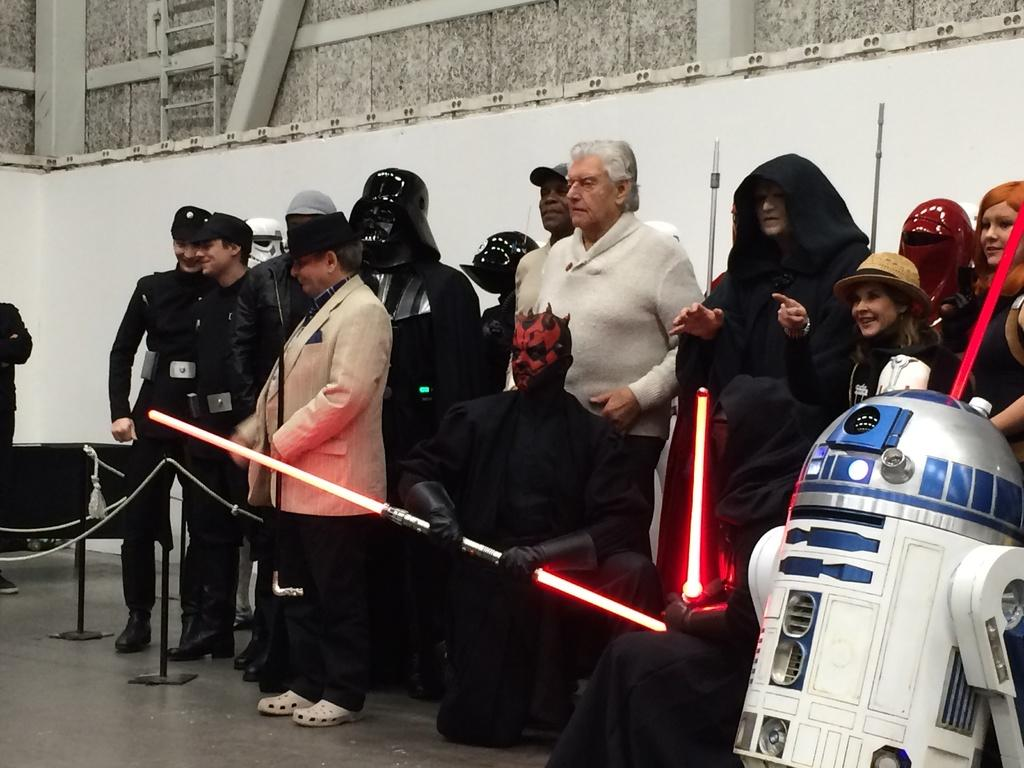What is the main subject in the foreground of the image? There is a crowd in the foreground of the image. What are the people in the crowd holding? The crowd is holding red lights. Where is the robot located in the image? The robot is in the right bottom corner of the image. What can be seen in the background of the image? There is a wall in the background of the image. What type of pan is being used by the crowd to wash the bit in the image? There is no pan, bit, or washing activity present in the image. 